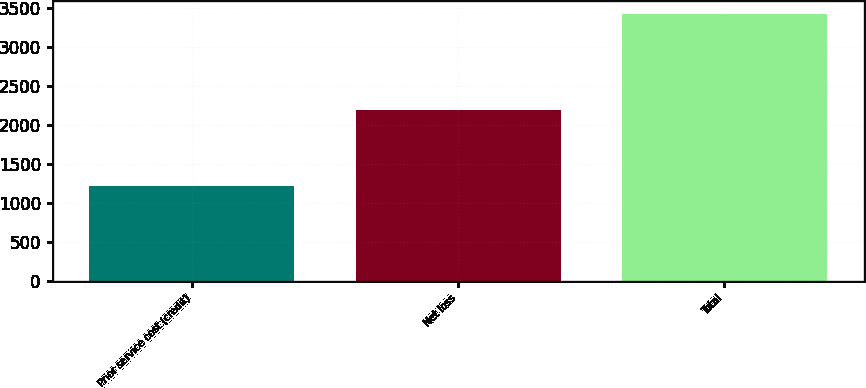<chart> <loc_0><loc_0><loc_500><loc_500><bar_chart><fcel>Prior service cost (credit)<fcel>Net loss<fcel>Total<nl><fcel>1215<fcel>2197<fcel>3412<nl></chart> 